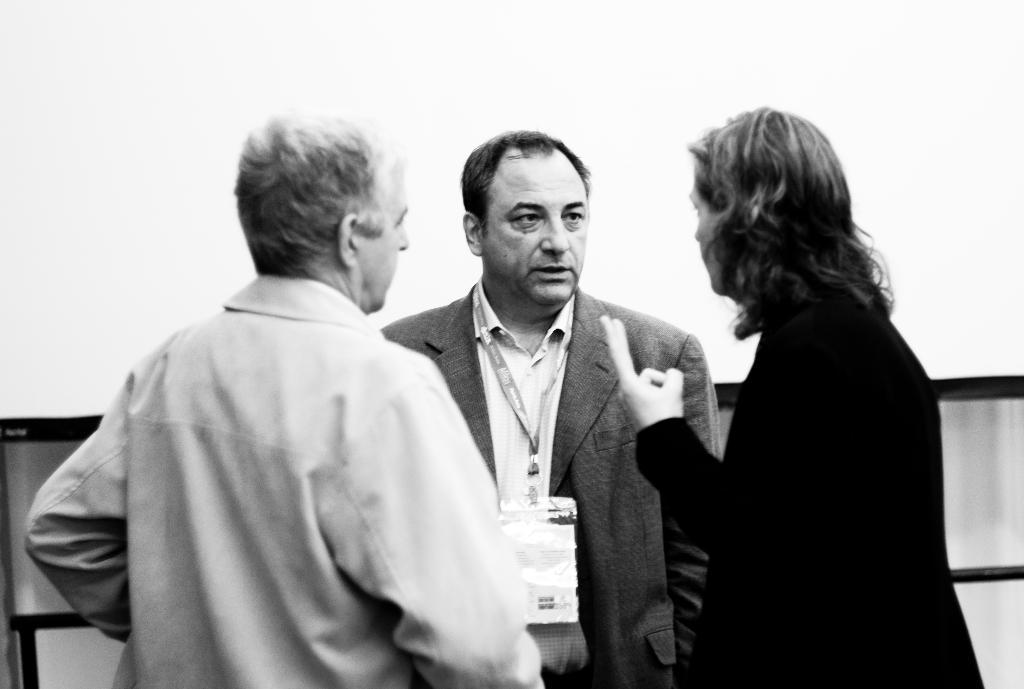Who or what can be seen in the image? There are people in the image. What is the color scheme of the image? The image is in black and white. What type of jewel is being displayed at the event in the image? There is no event or jewel present in the image; it only features people in black and white. 